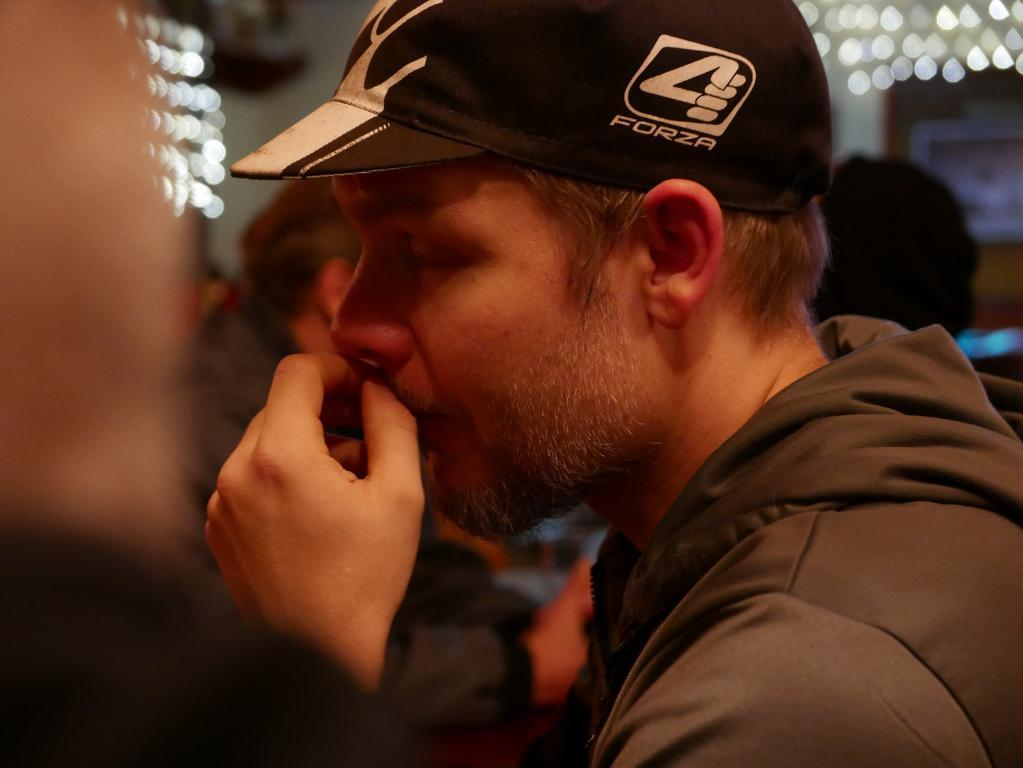How many people are in the image? There is a group of persons standing in the image. Can you describe the attire of one of the persons? One person is wearing a black dress and a cap. What can be seen in the background of the image? There are lights visible in the background of the image. What type of eggnog is being served by the owl in the image? There is no owl or eggnog present in the image. What is the person in the black dress pointing at in the image? The person in the black dress is not pointing at anything in the image. 